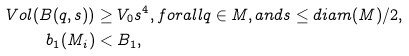<formula> <loc_0><loc_0><loc_500><loc_500>V o l ( B ( q , s ) ) & \geq V _ { 0 } s ^ { 4 } , f o r a l l q \in M , a n d s \leq d i a m ( M ) / 2 , \\ b _ { 1 } ( M _ { i } ) & < B _ { 1 } ,</formula> 